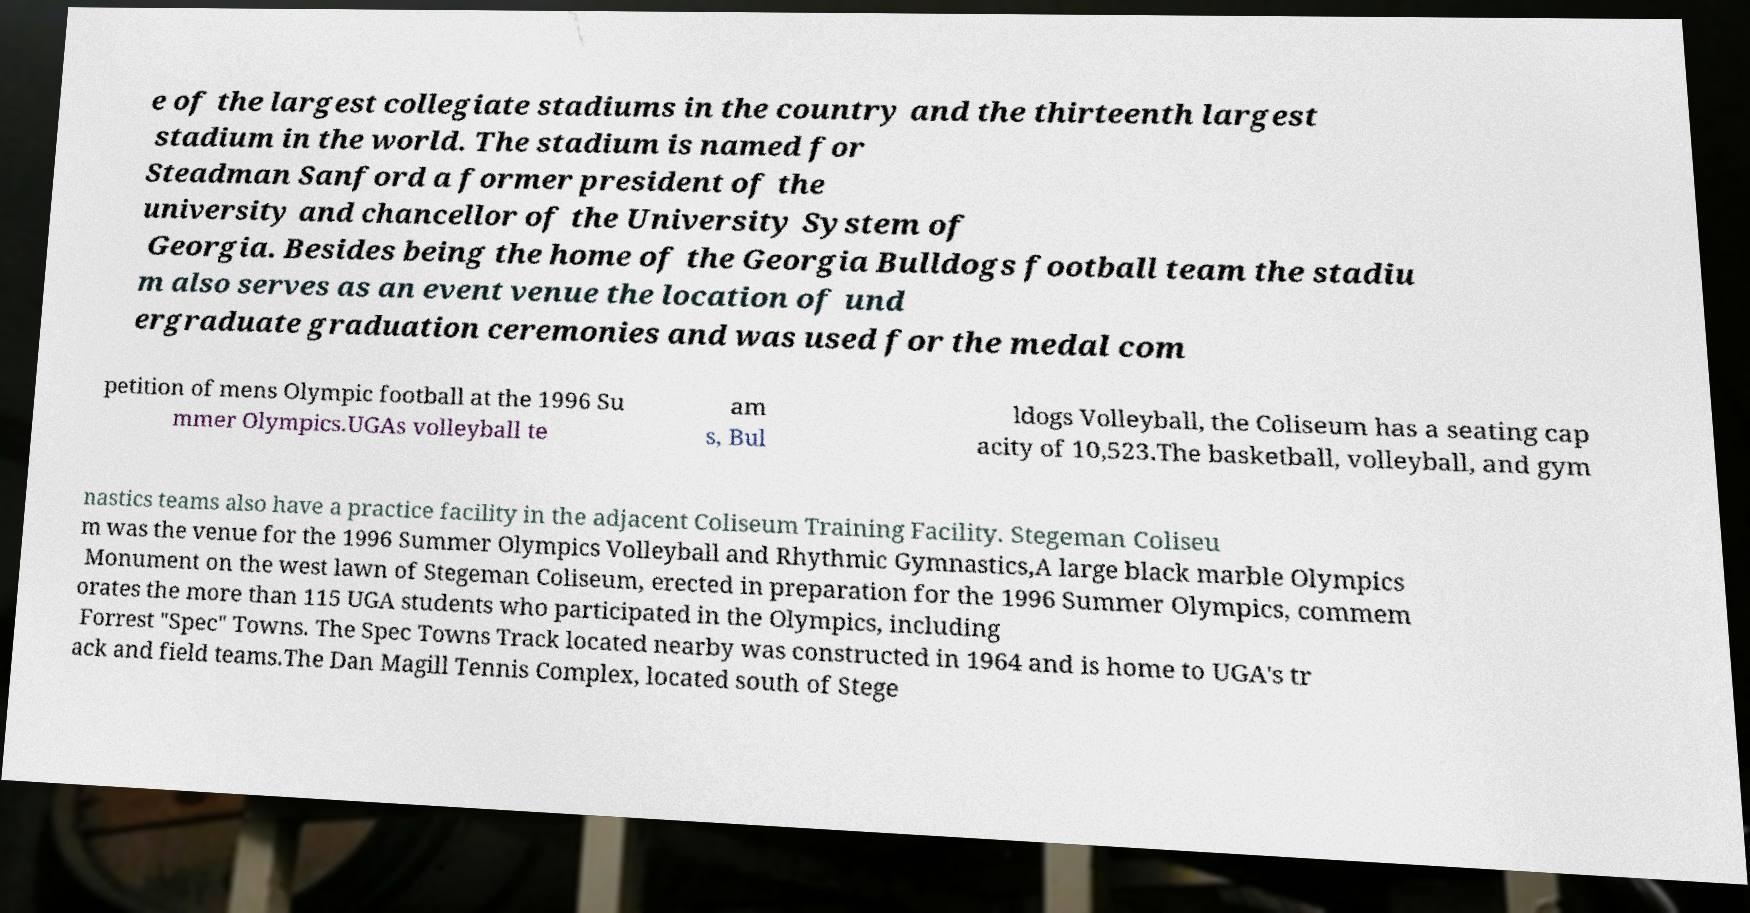Please identify and transcribe the text found in this image. e of the largest collegiate stadiums in the country and the thirteenth largest stadium in the world. The stadium is named for Steadman Sanford a former president of the university and chancellor of the University System of Georgia. Besides being the home of the Georgia Bulldogs football team the stadiu m also serves as an event venue the location of und ergraduate graduation ceremonies and was used for the medal com petition of mens Olympic football at the 1996 Su mmer Olympics.UGAs volleyball te am s, Bul ldogs Volleyball, the Coliseum has a seating cap acity of 10,523.The basketball, volleyball, and gym nastics teams also have a practice facility in the adjacent Coliseum Training Facility. Stegeman Coliseu m was the venue for the 1996 Summer Olympics Volleyball and Rhythmic Gymnastics,A large black marble Olympics Monument on the west lawn of Stegeman Coliseum, erected in preparation for the 1996 Summer Olympics, commem orates the more than 115 UGA students who participated in the Olympics, including Forrest "Spec" Towns. The Spec Towns Track located nearby was constructed in 1964 and is home to UGA's tr ack and field teams.The Dan Magill Tennis Complex, located south of Stege 